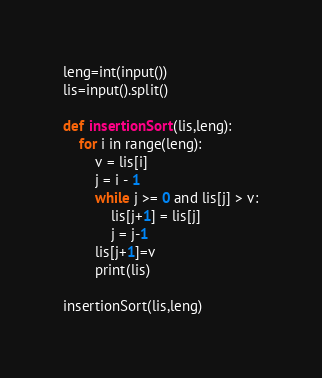Convert code to text. <code><loc_0><loc_0><loc_500><loc_500><_Python_>leng=int(input())
lis=input().split()

def insertionSort(lis,leng):
    for i in range(leng):
        v = lis[i]
        j = i - 1
        while j >= 0 and lis[j] > v:
            lis[j+1] = lis[j]
            j = j-1
        lis[j+1]=v
        print(lis)
        
insertionSort(lis,leng)</code> 